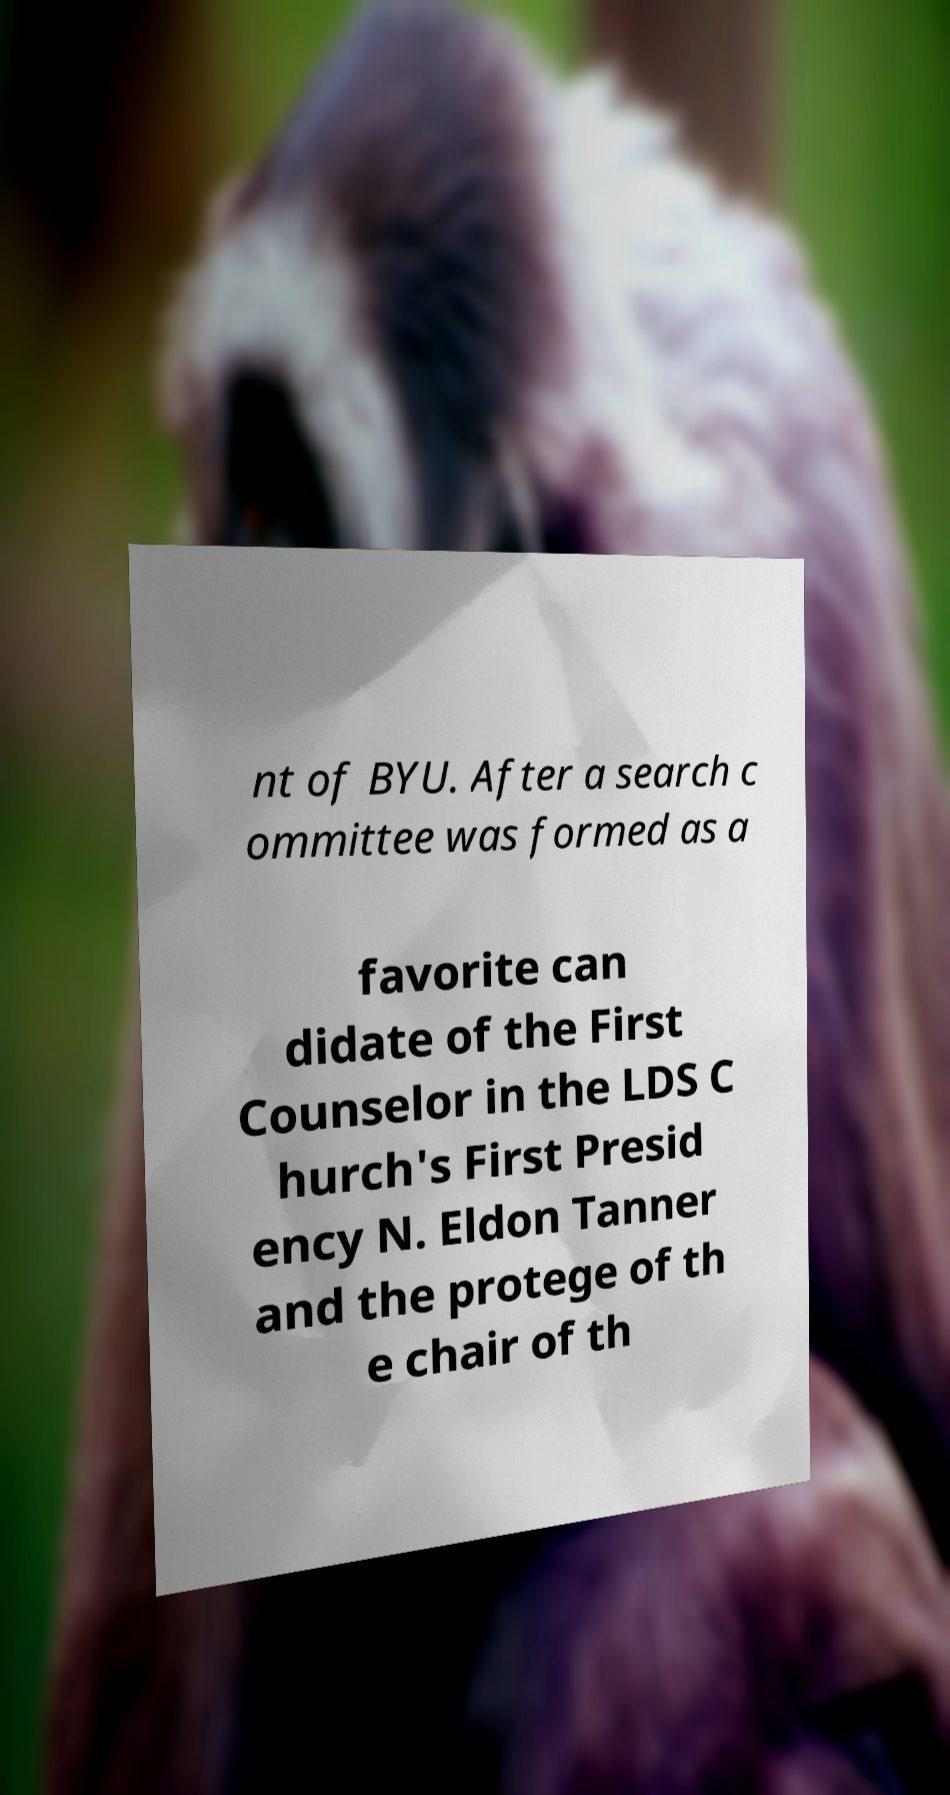Can you accurately transcribe the text from the provided image for me? nt of BYU. After a search c ommittee was formed as a favorite can didate of the First Counselor in the LDS C hurch's First Presid ency N. Eldon Tanner and the protege of th e chair of th 